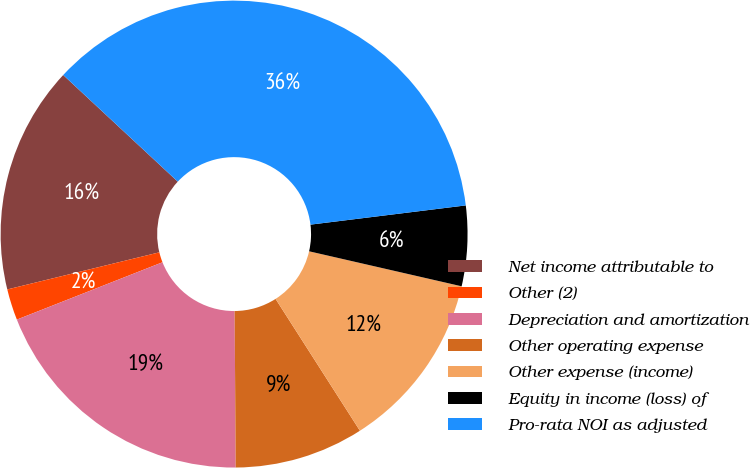Convert chart to OTSL. <chart><loc_0><loc_0><loc_500><loc_500><pie_chart><fcel>Net income attributable to<fcel>Other (2)<fcel>Depreciation and amortization<fcel>Other operating expense<fcel>Other expense (income)<fcel>Equity in income (loss) of<fcel>Pro-rata NOI as adjusted<nl><fcel>15.74%<fcel>2.16%<fcel>19.14%<fcel>8.95%<fcel>12.35%<fcel>5.55%<fcel>36.11%<nl></chart> 